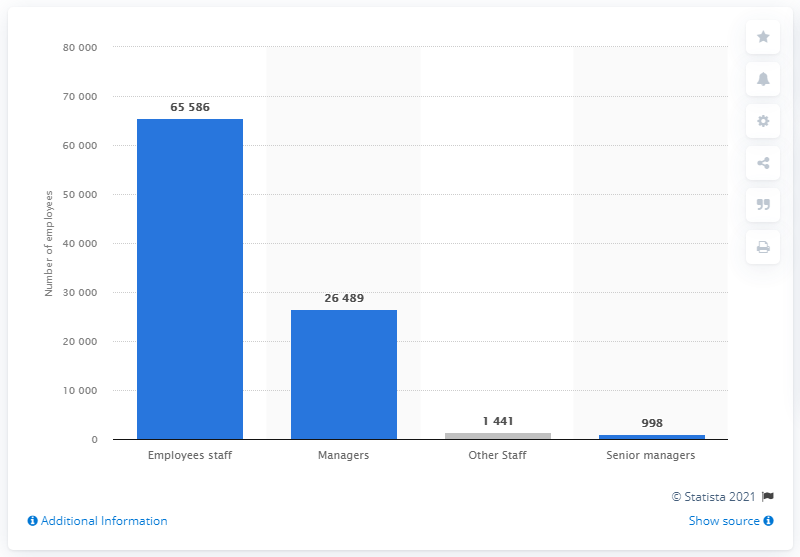Outline some significant characteristics in this image. In 2019, the Italian bank UniCredit had approximately 65,586 employees. In 2019, UniCredit employed 26,489 managers. 